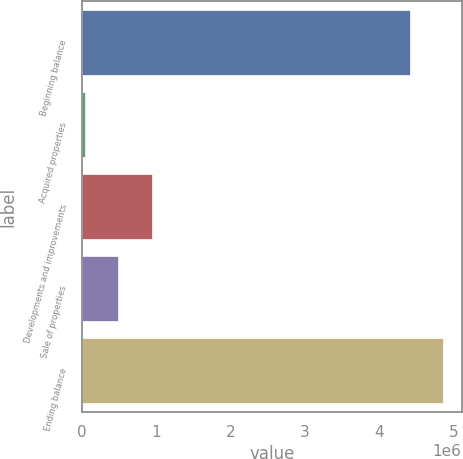Convert chart. <chart><loc_0><loc_0><loc_500><loc_500><bar_chart><fcel>Beginning balance<fcel>Acquired properties<fcel>Developments and improvements<fcel>Sale of properties<fcel>Ending balance<nl><fcel>4.40989e+06<fcel>39850<fcel>941060<fcel>490455<fcel>4.86049e+06<nl></chart> 